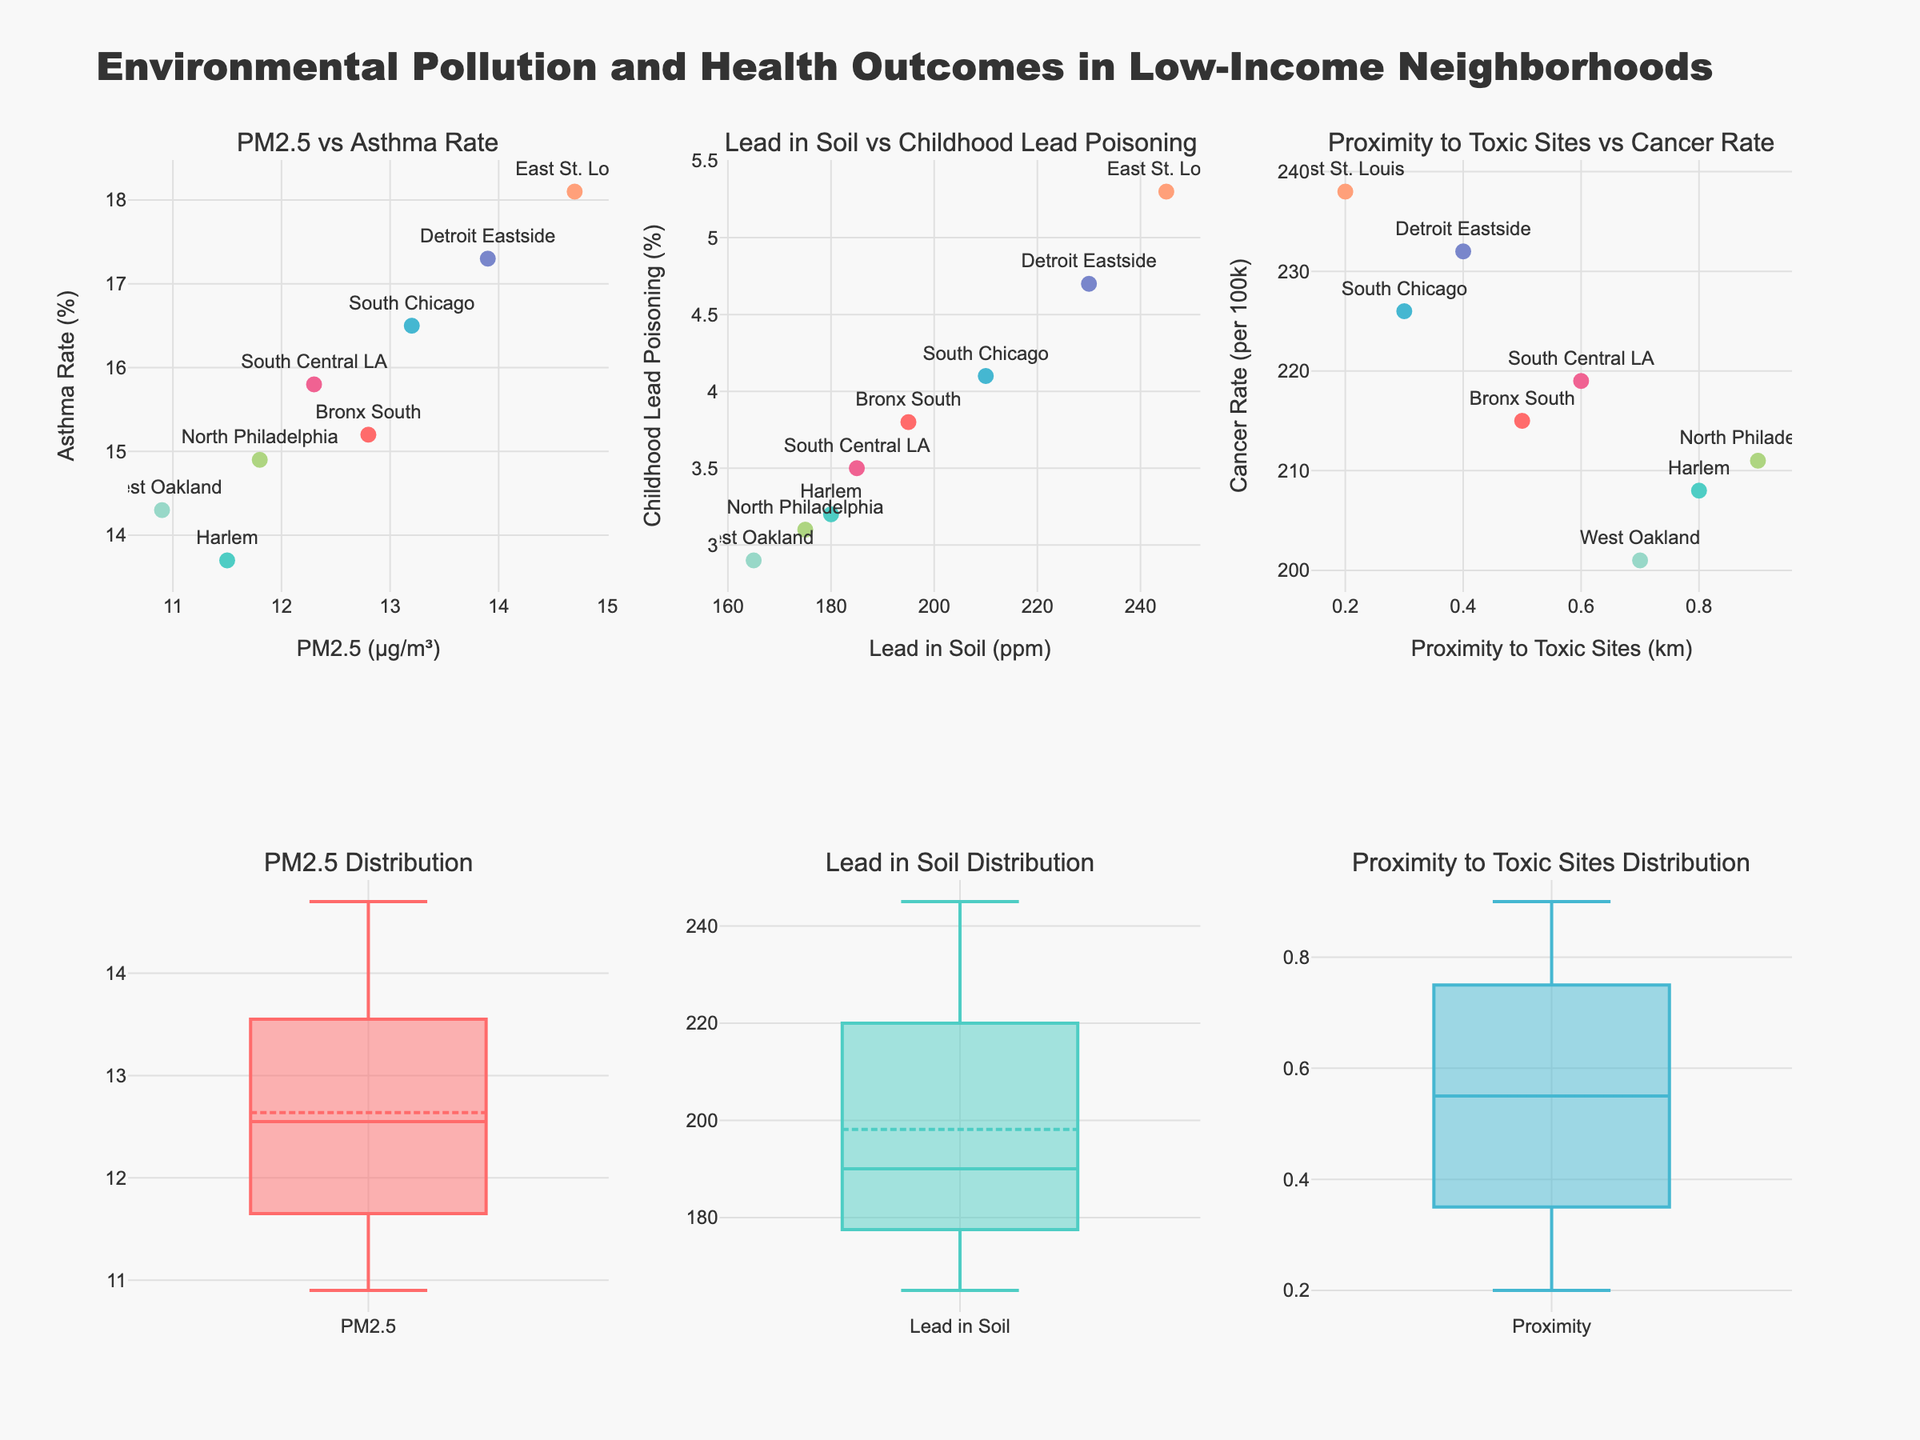What is the relationship between PM2.5 levels and asthma rates? To understand the relationship, look at the scatter plot in the top left. Note the trend formed by the data points for each neighborhood. Both axes are positively correlated, meaning neighborhoods with higher PM2.5 levels also tend to have higher asthma rates.
Answer: Positive correlation What neighborhood has the highest childhood lead poisoning rate and how much is it? Refer to the scatter plot in the top middle showing Lead in Soil vs Childhood Lead Poisoning rates. Find the neighborhood at the highest y-axis value, which is East St. Louis.
Answer: East St. Louis, 5.3% Which neighborhood has the closest proximity to toxic sites? Check the scatter plot on the top right for Proximity to Toxic Sites vs Cancer Rate. The neighborhood with the smallest x-axis value is East St. Louis.
Answer: East St. Louis Compare the average levels of PM2.5 and Lead in Soil across all neighborhoods. Which is higher on average? Use the box plots in the bottom row to compare. The median line within each box represents the average. PM2.5 box plot median appears lower compared to the Lead in Soil box plot median.
Answer: Lead in Soil Is there a neighborhood that stands out in having both low PM2.5 levels and low asthma rates? Look at the scatter plot in the top left for neighborhoods with lower values on both axes. West Oakland and Harlem show both low PM2.5 and asthma rates.
Answer: West Oakland or Harlem What can you infer about cancer rates in relation to proximity to toxic sites? Assess the scatter plot in the top right corner. Neighborhoods closer to toxic sites don't consistently show higher cancer rates, thus no clear trend in data.
Answer: No clear trend Which neighborhood has the highest cancer rate and what is it? Refer to the scatter plot in the top right. The highest y-axis value, corresponding to the cancer rate, is for East St. Louis.
Answer: East St. Louis, 238 per 100k Compare Detroit Eastside and South Chicago in terms of lead in soil levels. Which neighborhood has a higher level? Look at the scatter plot in the top middle for Lead in Soil vs Childhood Lead Poisoning rates. Detroit Eastside's x-value (230 ppm) is higher compared to South Chicago's (210 ppm).
Answer: Detroit Eastside How variable are the PM2.5 levels across neighborhoods? Examine the box plot in the bottom left. The spread of the box and the length of the whiskers indicate data variability. The PM2.5 levels have low spread with few outliers, indicating low variability.
Answer: Low variability Which neighborhood has the lowest asthma rate and what's its value? Refer to the scatter plot on the top left. The lowest y-value corresponds to Harlem with an asthma rate of 13.7%.
Answer: Harlem, 13.7% 